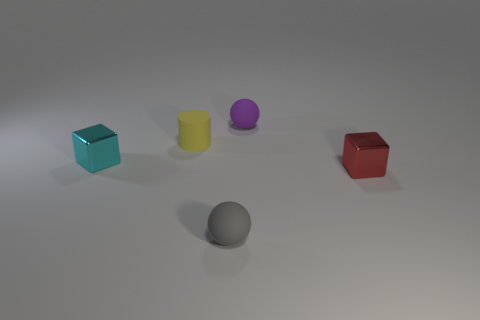Add 3 small gray rubber objects. How many objects exist? 8 Subtract all blocks. How many objects are left? 3 Add 2 small red shiny things. How many small red shiny things exist? 3 Subtract 1 cyan cubes. How many objects are left? 4 Subtract all small cylinders. Subtract all small yellow rubber cylinders. How many objects are left? 3 Add 4 tiny purple rubber things. How many tiny purple rubber things are left? 5 